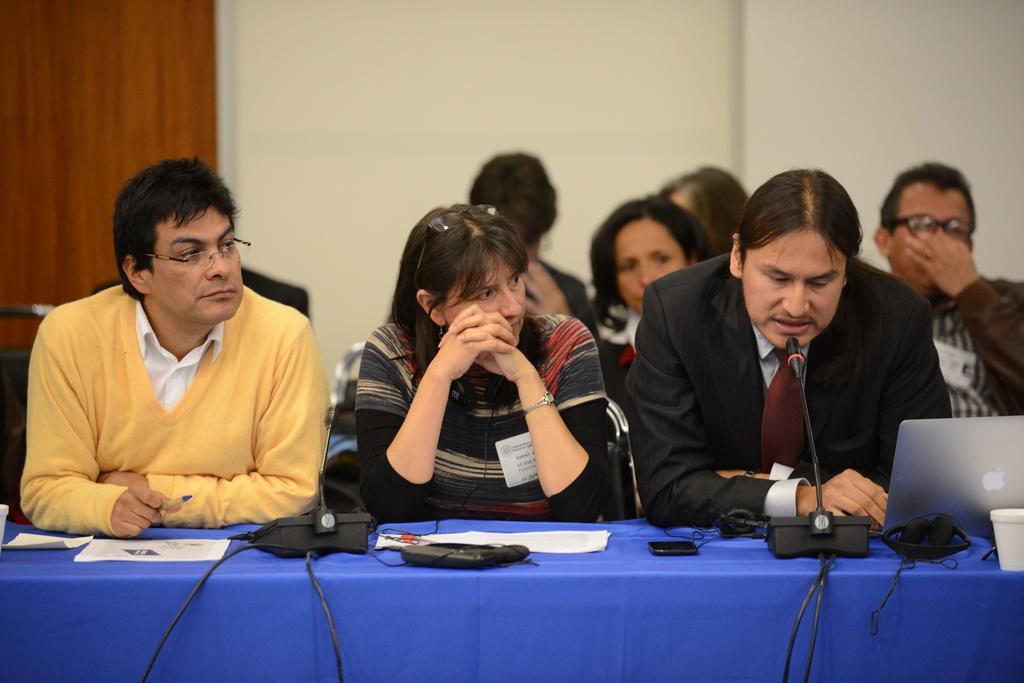Could you give a brief overview of what you see in this image? In this image we can see many people sitting on the chairs. There are few objects on the table. There is a laptop at the right side of the image. There are few cables in the image. A person is speaking into a microphone. We can see the wall in the image. There is a wooden object at the left side of the image. 